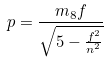Convert formula to latex. <formula><loc_0><loc_0><loc_500><loc_500>p = \frac { m _ { 8 } f } { \sqrt { 5 - \frac { f ^ { 2 } } { n ^ { 2 } } } }</formula> 